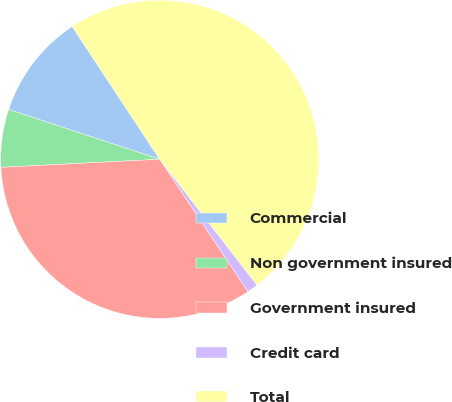<chart> <loc_0><loc_0><loc_500><loc_500><pie_chart><fcel>Commercial<fcel>Non government insured<fcel>Government insured<fcel>Credit card<fcel>Total<nl><fcel>10.65%<fcel>5.88%<fcel>33.55%<fcel>1.11%<fcel>48.8%<nl></chart> 